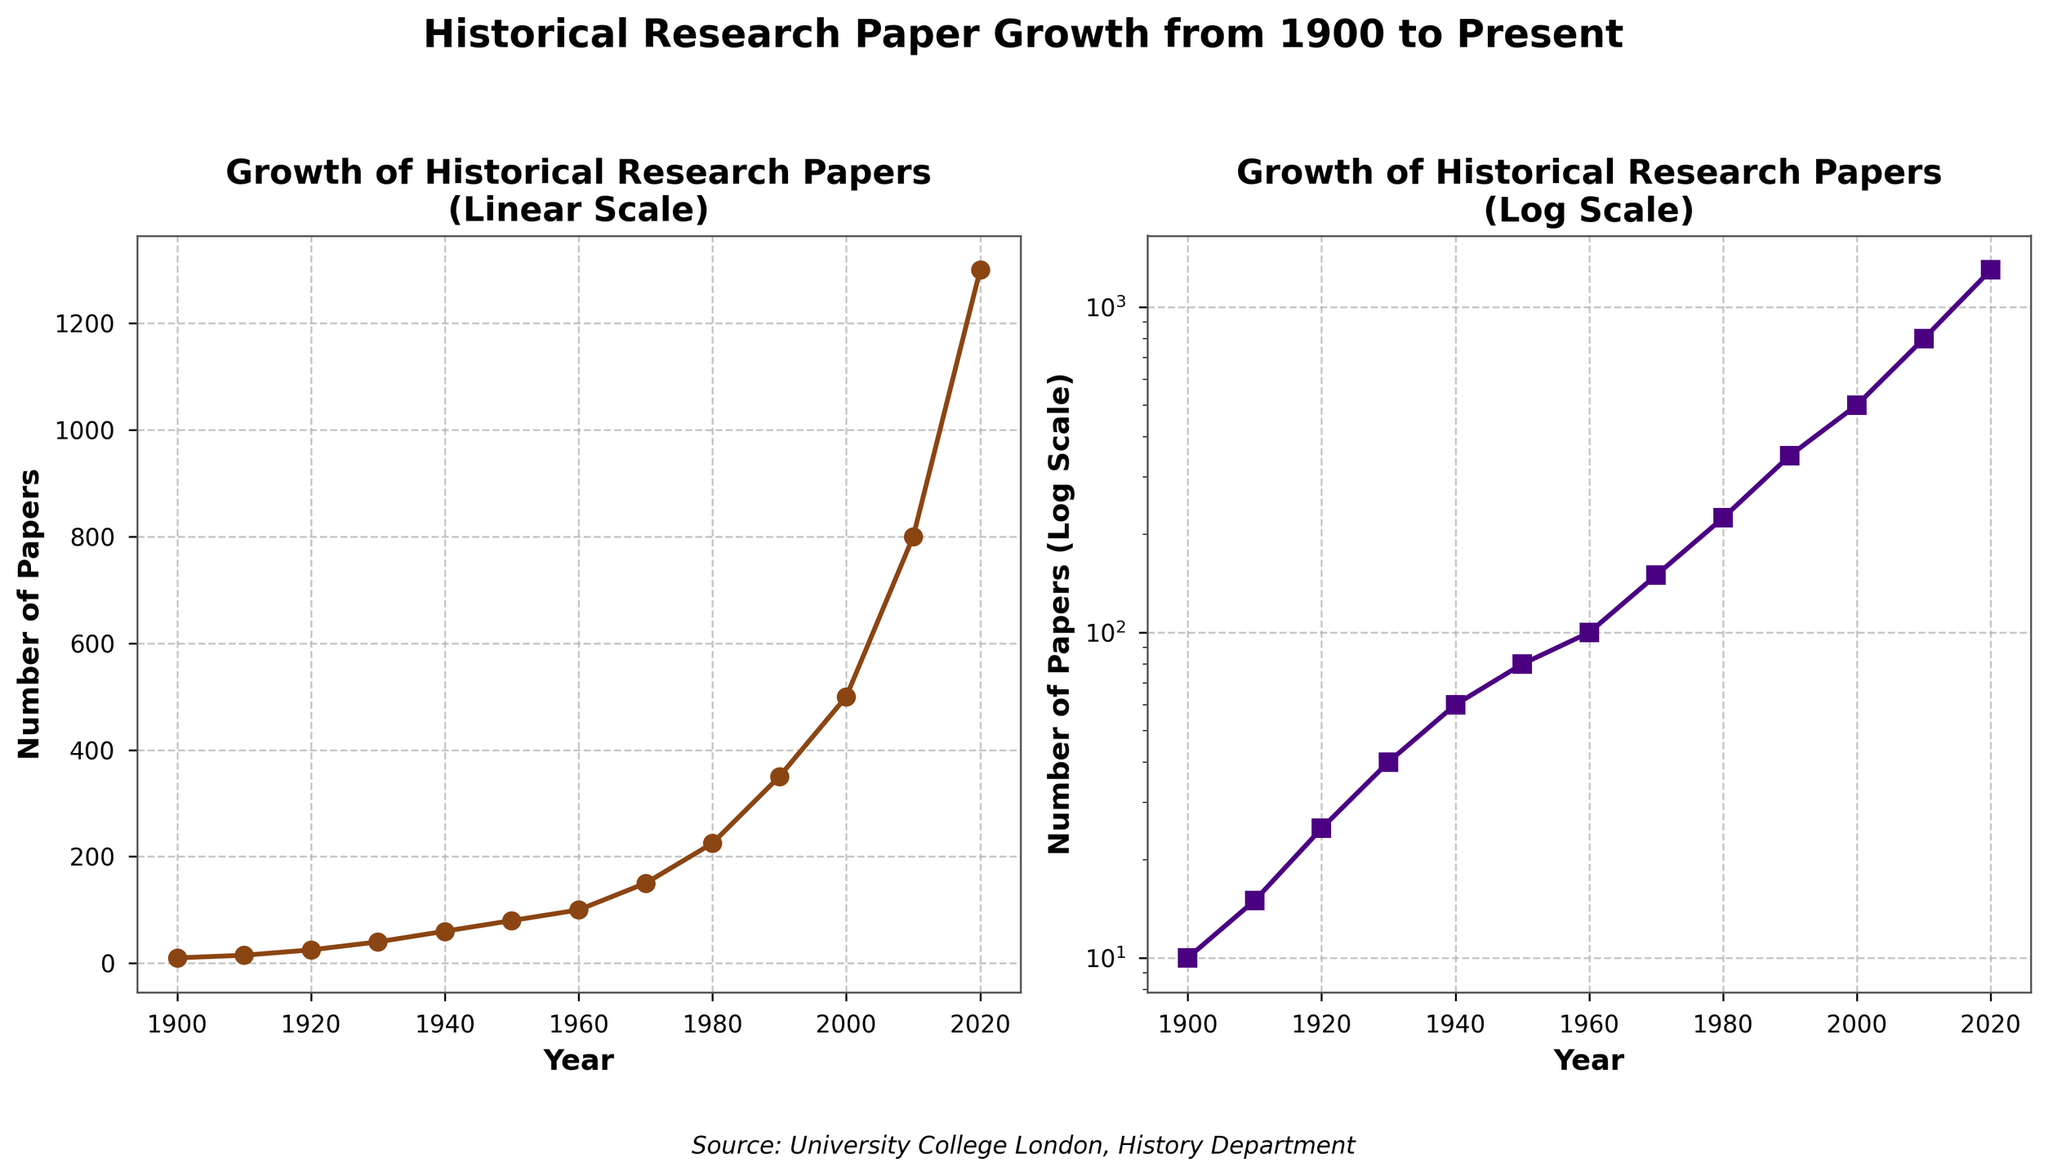what is the title of the second subplot? Both subplots have clear titles at the top of each plot. The second subplot's title is "Growth of Historical Research Papers (Log Scale)"
Answer: Growth of Historical Research Papers (Log Scale) What is the marker shape used in the log scale plot? The log scale plot uses square markers, which can be seen from the shape of each data point on the second subplot.
Answer: Square How many data points are plotted on the log scale plot? There are markers at each year listed, spanning from 1900 to 2020. Counting these, there are 13 data points.
Answer: 13 What is the color of the line in the linear scale plot? The linear scale plot uses a brownish color for the line connecting the data points.
Answer: Brownish (dark brown) Which year has the highest number of published papers on the log scale plot? The log scale plot shows that the number of papers increases over time, and the highest value is 1300 in 2020.
Answer: 2020 What was the approximate number of papers published in 1950? The log scale plot shows that around 80 papers were published in 1950. This can be determined by locating 1950 on the x-axis and seeing the nearest data point on the y-axis.
Answer: 80 What is the difference in the number of papers published between 1940 and 1980? Looking at the log scale plot, there were about 60 papers in 1940 and about 225 papers in 1980. The difference is 225 - 60 = 165 papers.
Answer: 165 How does the slope of the growth curve change in the log scale compared to the linear scale? In the log scale plot, the growth curve becomes more linear over time, indicating exponential growth. In the linear scale, the same growth appears more curved, showing a rapid increase especially in recent years.
Answer: More linear in log scale In which decade did the number of papers grow from 150 to 350? Observing the log scale plot, the number of papers was 150 around the 1970s and 350 around the 1990s. Hence, the growth from 150 to 350 happened between the 1970s and 1990s.
Answer: 1970s to 1990s What can you infer about the growth rate of published historical papers from 1900 to the present? Both plots show an increasing trend, but the log scale plot, in particular, reveals that the number of published historical papers has been growing exponentially over the past century. This is evidenced by the more linear appearance of the growth curve on the log plot.
Answer: Exponential growth 